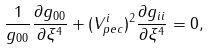<formula> <loc_0><loc_0><loc_500><loc_500>\frac { 1 } { g _ { 0 0 } } \frac { \partial { g _ { 0 0 } } } { \partial { \xi ^ { 4 } } } + ( V ^ { i } _ { p e c } ) ^ { 2 } \frac { \partial { g _ { i i } } } { \partial { \xi ^ { 4 } } } = 0 ,</formula> 